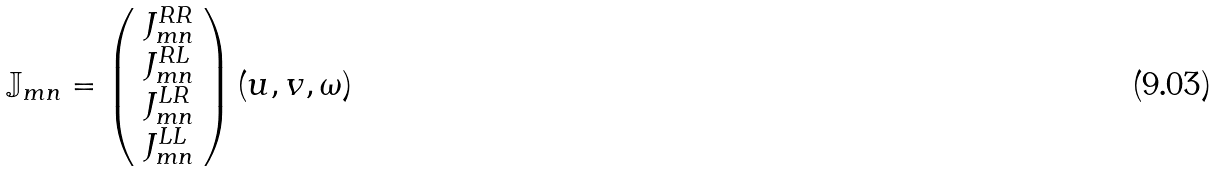<formula> <loc_0><loc_0><loc_500><loc_500>\mathbb { J } _ { m n } = \left ( \begin{array} { c } J ^ { R R } _ { m n } \\ J ^ { R L } _ { m n } \\ J ^ { L R } _ { m n } \\ J ^ { L L } _ { m n } \\ \end{array} \right ) ( u , v , \omega )</formula> 